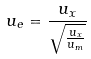<formula> <loc_0><loc_0><loc_500><loc_500>u _ { e } = \frac { u _ { x } } { \sqrt { \frac { u _ { x } } { u _ { m } } } }</formula> 